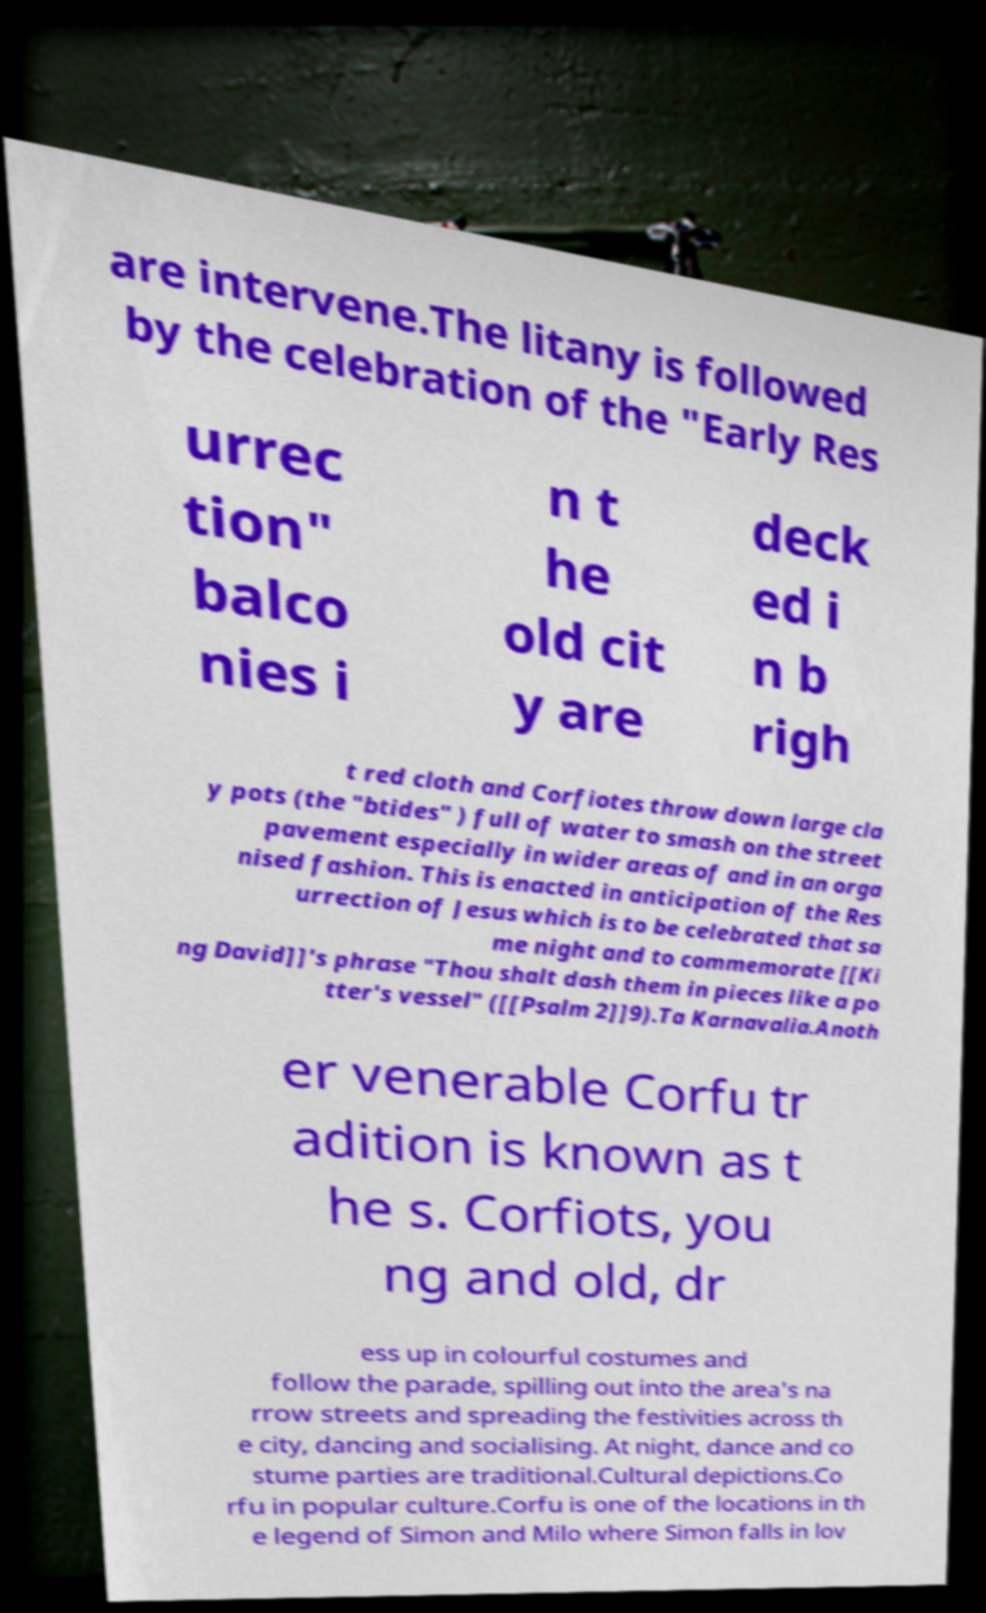Could you assist in decoding the text presented in this image and type it out clearly? are intervene.The litany is followed by the celebration of the "Early Res urrec tion" balco nies i n t he old cit y are deck ed i n b righ t red cloth and Corfiotes throw down large cla y pots (the "btides" ) full of water to smash on the street pavement especially in wider areas of and in an orga nised fashion. This is enacted in anticipation of the Res urrection of Jesus which is to be celebrated that sa me night and to commemorate [[Ki ng David]]'s phrase "Thou shalt dash them in pieces like a po tter's vessel" ([[Psalm 2]]9).Ta Karnavalia.Anoth er venerable Corfu tr adition is known as t he s. Corfiots, you ng and old, dr ess up in colourful costumes and follow the parade, spilling out into the area's na rrow streets and spreading the festivities across th e city, dancing and socialising. At night, dance and co stume parties are traditional.Cultural depictions.Co rfu in popular culture.Corfu is one of the locations in th e legend of Simon and Milo where Simon falls in lov 